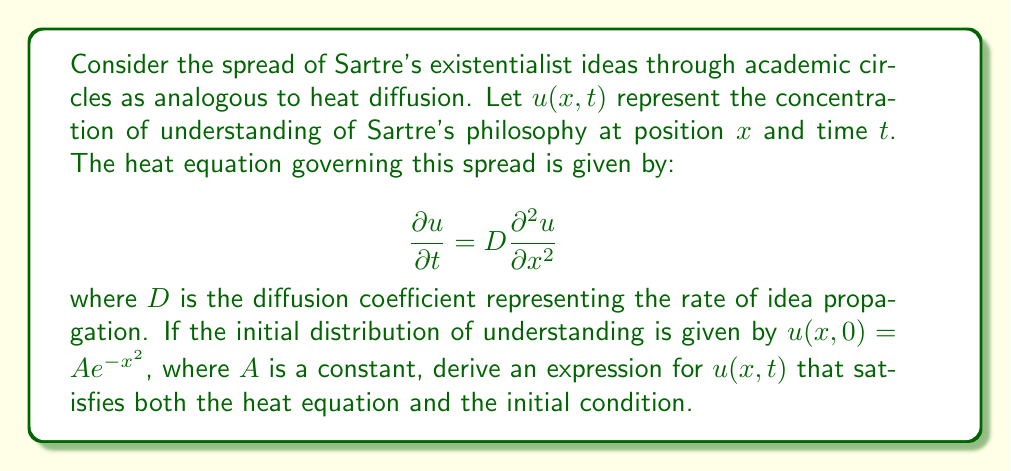Give your solution to this math problem. To solve this problem, we'll use the method of separation of variables and Fourier transforms.

1) We start by assuming a solution of the form $u(x,t) = X(x)T(t)$.

2) Substituting this into the heat equation:

   $$X(x)\frac{dT}{dt} = DT(t)\frac{d^2X}{dx^2}$$

3) Dividing both sides by $DX(x)T(t)$:

   $$\frac{1}{DT}\frac{dT}{dt} = \frac{1}{X}\frac{d^2X}{dx^2}$$

4) Since the left side depends only on $t$ and the right side only on $x$, both must equal a constant, say $-k^2$:

   $$\frac{1}{T}\frac{dT}{dt} = -Dk^2$$
   $$\frac{d^2X}{dx^2} = -k^2X$$

5) Solving these equations:

   $$T(t) = Ce^{-Dk^2t}$$
   $$X(x) = A\cos(kx) + B\sin(kx)$$

6) The general solution is thus:

   $$u(x,t) = \int_0^\infty [A(k)\cos(kx) + B(k)\sin(kx)]e^{-Dk^2t}dk$$

7) Given the initial condition $u(x,0) = Ae^{-x^2}$, we need to find $A(k)$ and $B(k)$.

8) At $t=0$:

   $$Ae^{-x^2} = \int_0^\infty [A(k)\cos(kx) + B(k)\sin(kx)]dk$$

9) This is the Fourier transform of $Ae^{-x^2}$. The Fourier transform of a Gaussian is another Gaussian:

   $$A(k) = \frac{A\sqrt{\pi}}{2}e^{-k^2/4}, B(k) = 0$$

10) Substituting back into the general solution:

    $$u(x,t) = \frac{A\sqrt{\pi}}{2}\int_0^\infty e^{-k^2/4}\cos(kx)e^{-Dk^2t}dk$$

11) This integral can be evaluated to yield:

    $$u(x,t) = \frac{A}{\sqrt{1+4Dt}}e^{-x^2/(1+4Dt)}$$

This solution satisfies both the heat equation and the initial condition.
Answer: $$u(x,t) = \frac{A}{\sqrt{1+4Dt}}e^{-x^2/(1+4Dt)}$$ 